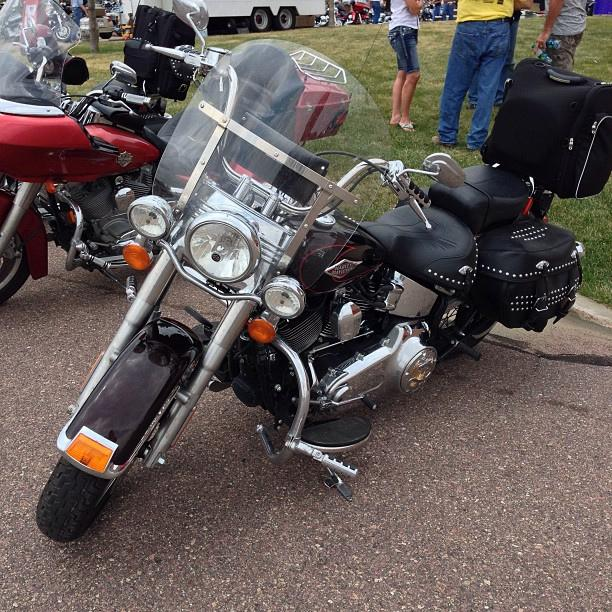Why is the man holding plastic bottles? very thirsty 